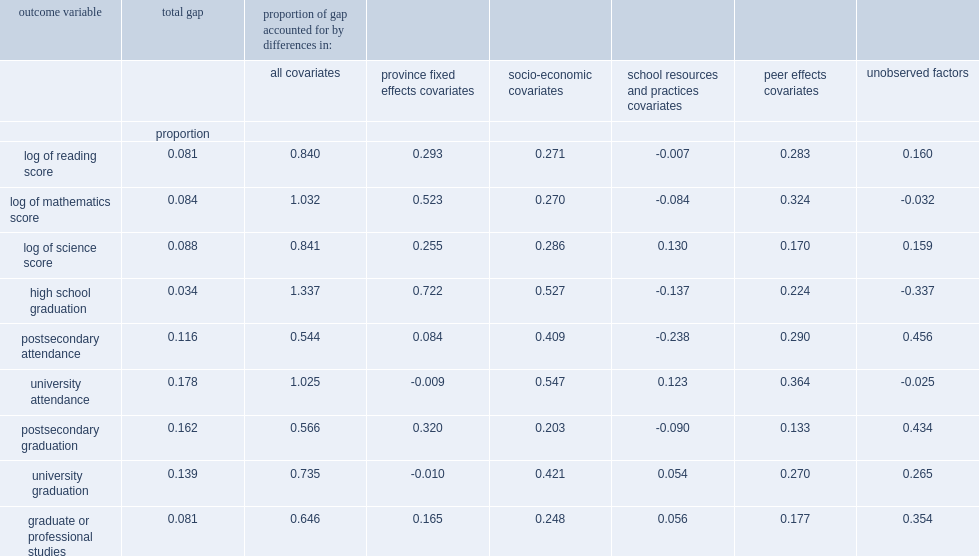What the percent of the gaps did school resources and practices account for and at times, their contribution was negative? 0.13. 